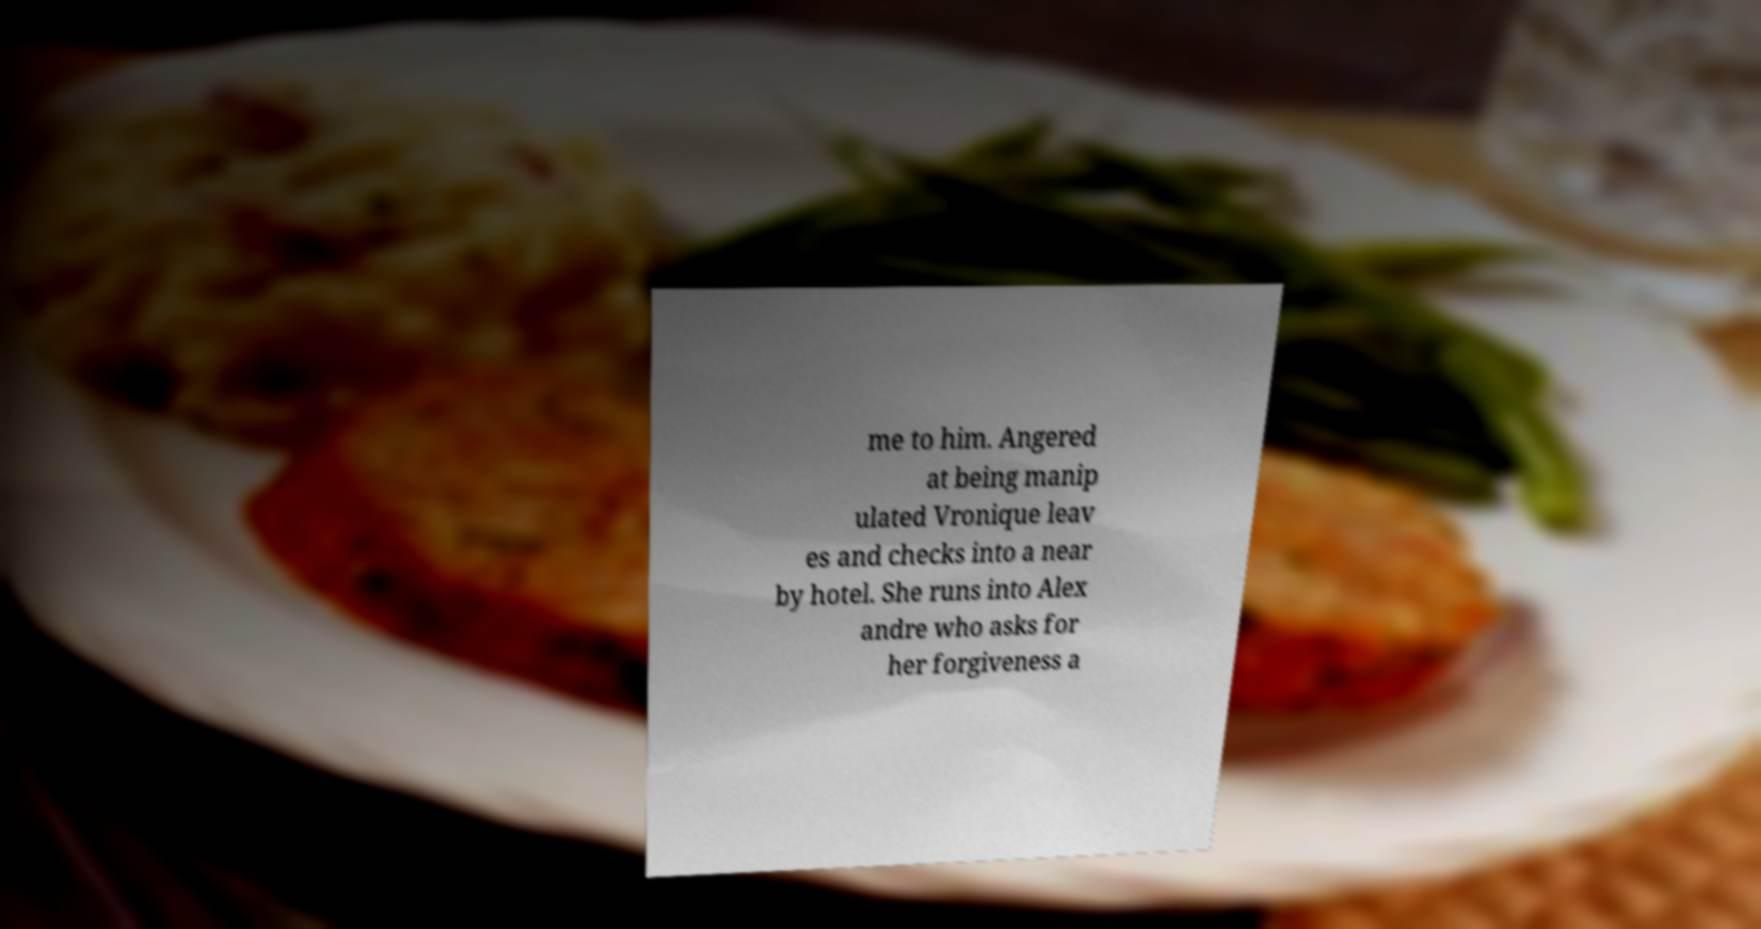There's text embedded in this image that I need extracted. Can you transcribe it verbatim? me to him. Angered at being manip ulated Vronique leav es and checks into a near by hotel. She runs into Alex andre who asks for her forgiveness a 